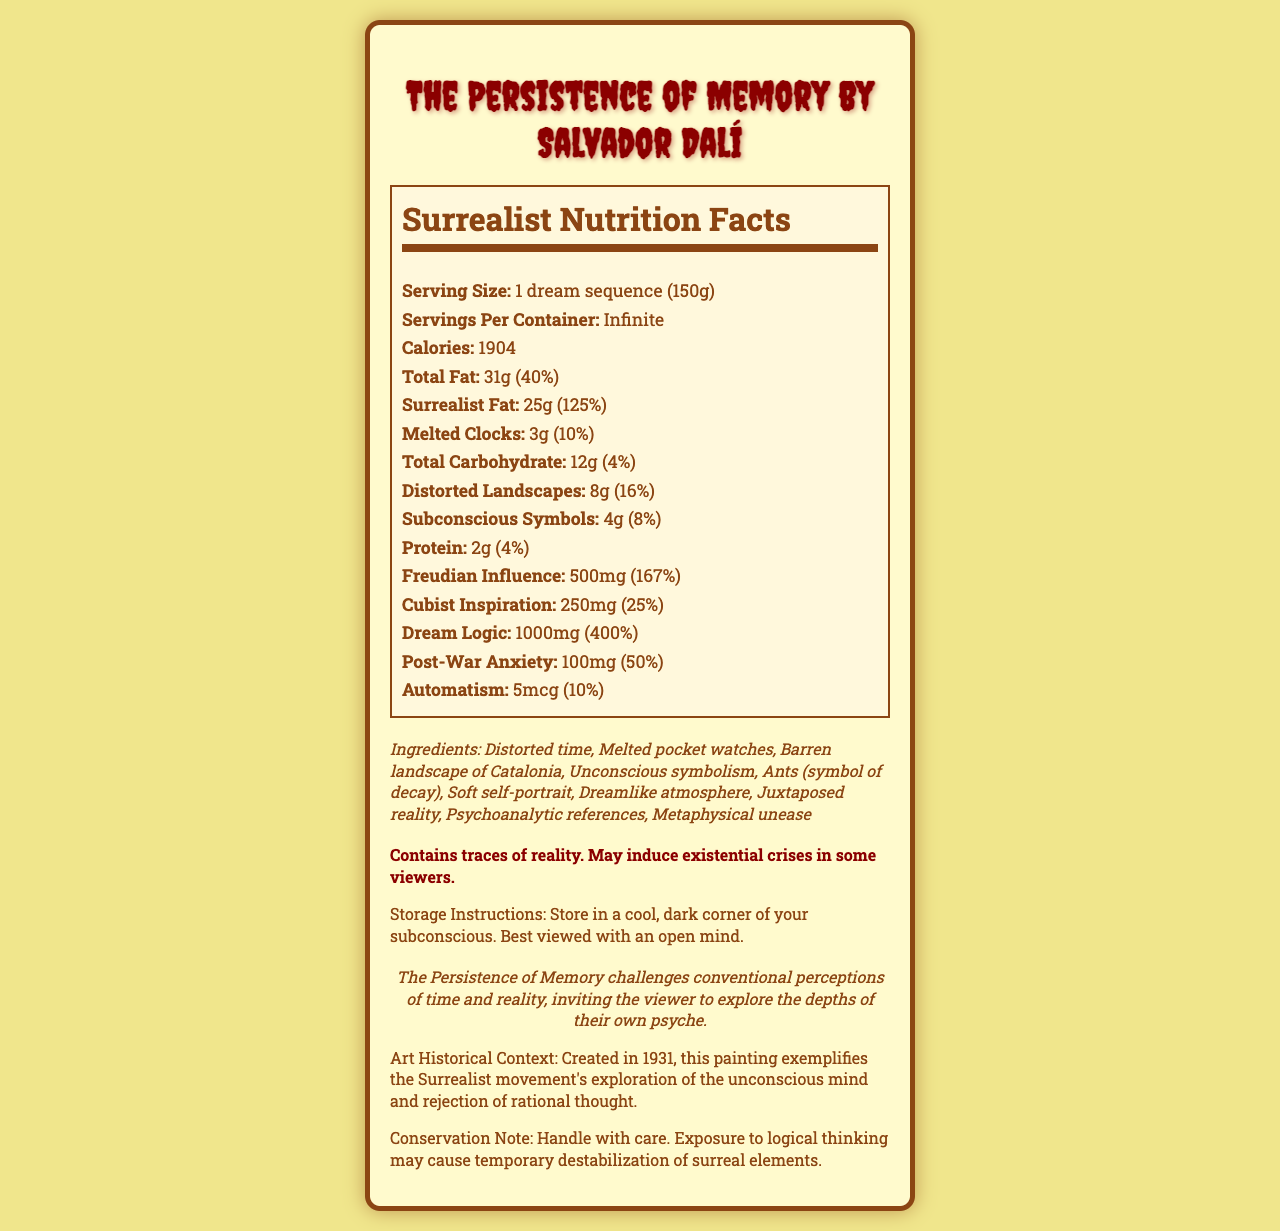what is the serving size? The serving size stated on the label is "1 dream sequence (150g)."
Answer: 1 dream sequence (150g) how many calories are in one serving? The label specifies that there are 1904 calories per serving.
Answer: 1904 what percentage of daily value does surrealist fat represent? The label indicates that surrealist fat represents 125% of the daily value.
Answer: 125% what ingredients are listed on the label? The label lists all these ingredients.
Answer: Distorted time, Melted pocket watches, Barren landscape of Catalonia, Unconscious symbolism, Ants (symbol of decay), Soft self-portrait, Dreamlike atmosphere, Juxtaposed reality, Psychoanalytic references, Metaphysical unease how should the product be stored? The storage instructions on the label suggest storing in a cool, dark corner of your subconscious and viewing it with an open mind.
Answer: Store in a cool, dark corner of your subconscious. Best viewed with an open mind. which element is in the largest amount: freudian influence, cubist inspiration, or dream logic? Dream logic is listed as 1000mg (400% daily value), whereas freudian influence is 500mg (167%), and cubist inspiration is 250mg (25%).
Answer: Dream logic how much melted clocks are in one serving? The label indicates that there are 3g of melted clocks per serving.
Answer: 3g which of the following is NOT one of the ingredients listed on the label? A. Melted pocket watches B. Soft self-portrait C. Salvador Dalí's mustache Ingredients A and B are listed, but Salvador Dalí's mustache is not mentioned.
Answer: C. Salvador Dalí's mustache what is the primary theme of the artist statement? A. The relationship between space and time B. The challenge of conventional perceptions C. The influence of other artists The artist statement indicates that the piece challenges conventional perceptions of time and reality.
Answer: B. The challenge of conventional perceptions does the document mention any potential allergies? The allergen warning states that the product contains traces of reality and may induce existential crises.
Answer: Yes summarize the main idea of the document This explanation covers the detailed content and overarching theme presented in the document.
Answer: The document is a surreal Nutrition Facts label for Salvador Dalí's painting "The Persistence of Memory." It presents various surreal elements as nutritional components, indicating serving sizes, daily values, and ingredients. The document aims to reflect the themes of surrealism and challenge conventional perceptions of reality. what is the year of creation for "The Persistence of Memory"? The year of creation is not explicitly mentioned in the visual information provided in the document, hence it cannot be determined from the label.
Answer: Cannot be determined 